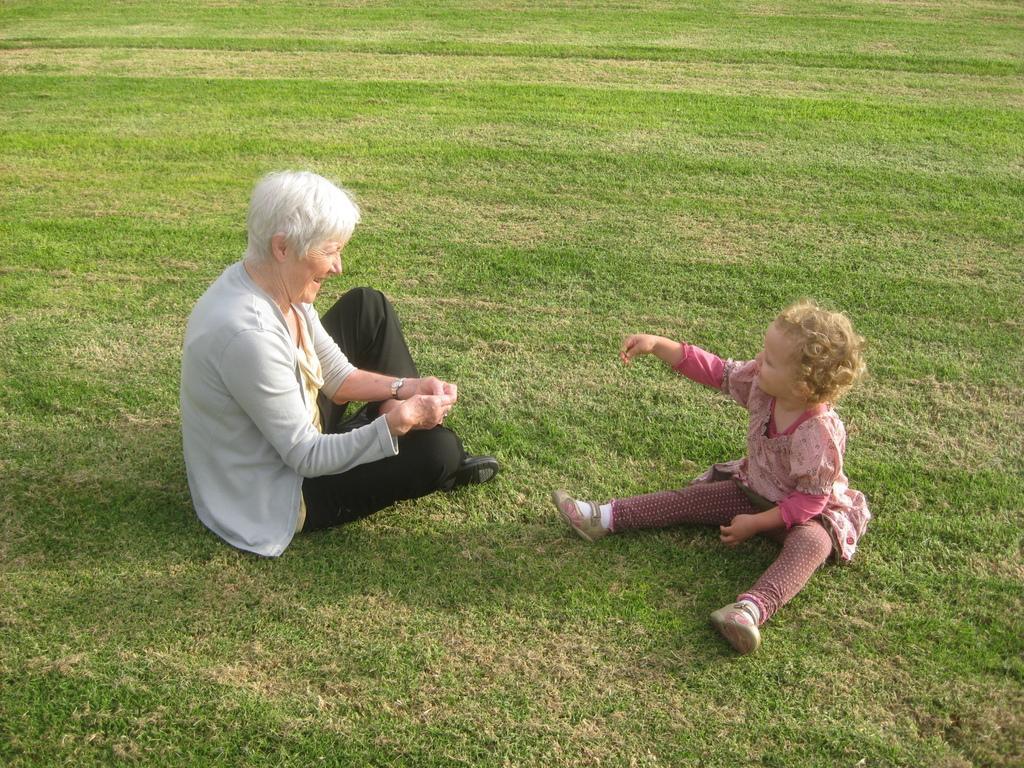Describe this image in one or two sentences. In the image a woman and a kid are sitting on the grass, both of them are looking at each other and the woman is laughing. 